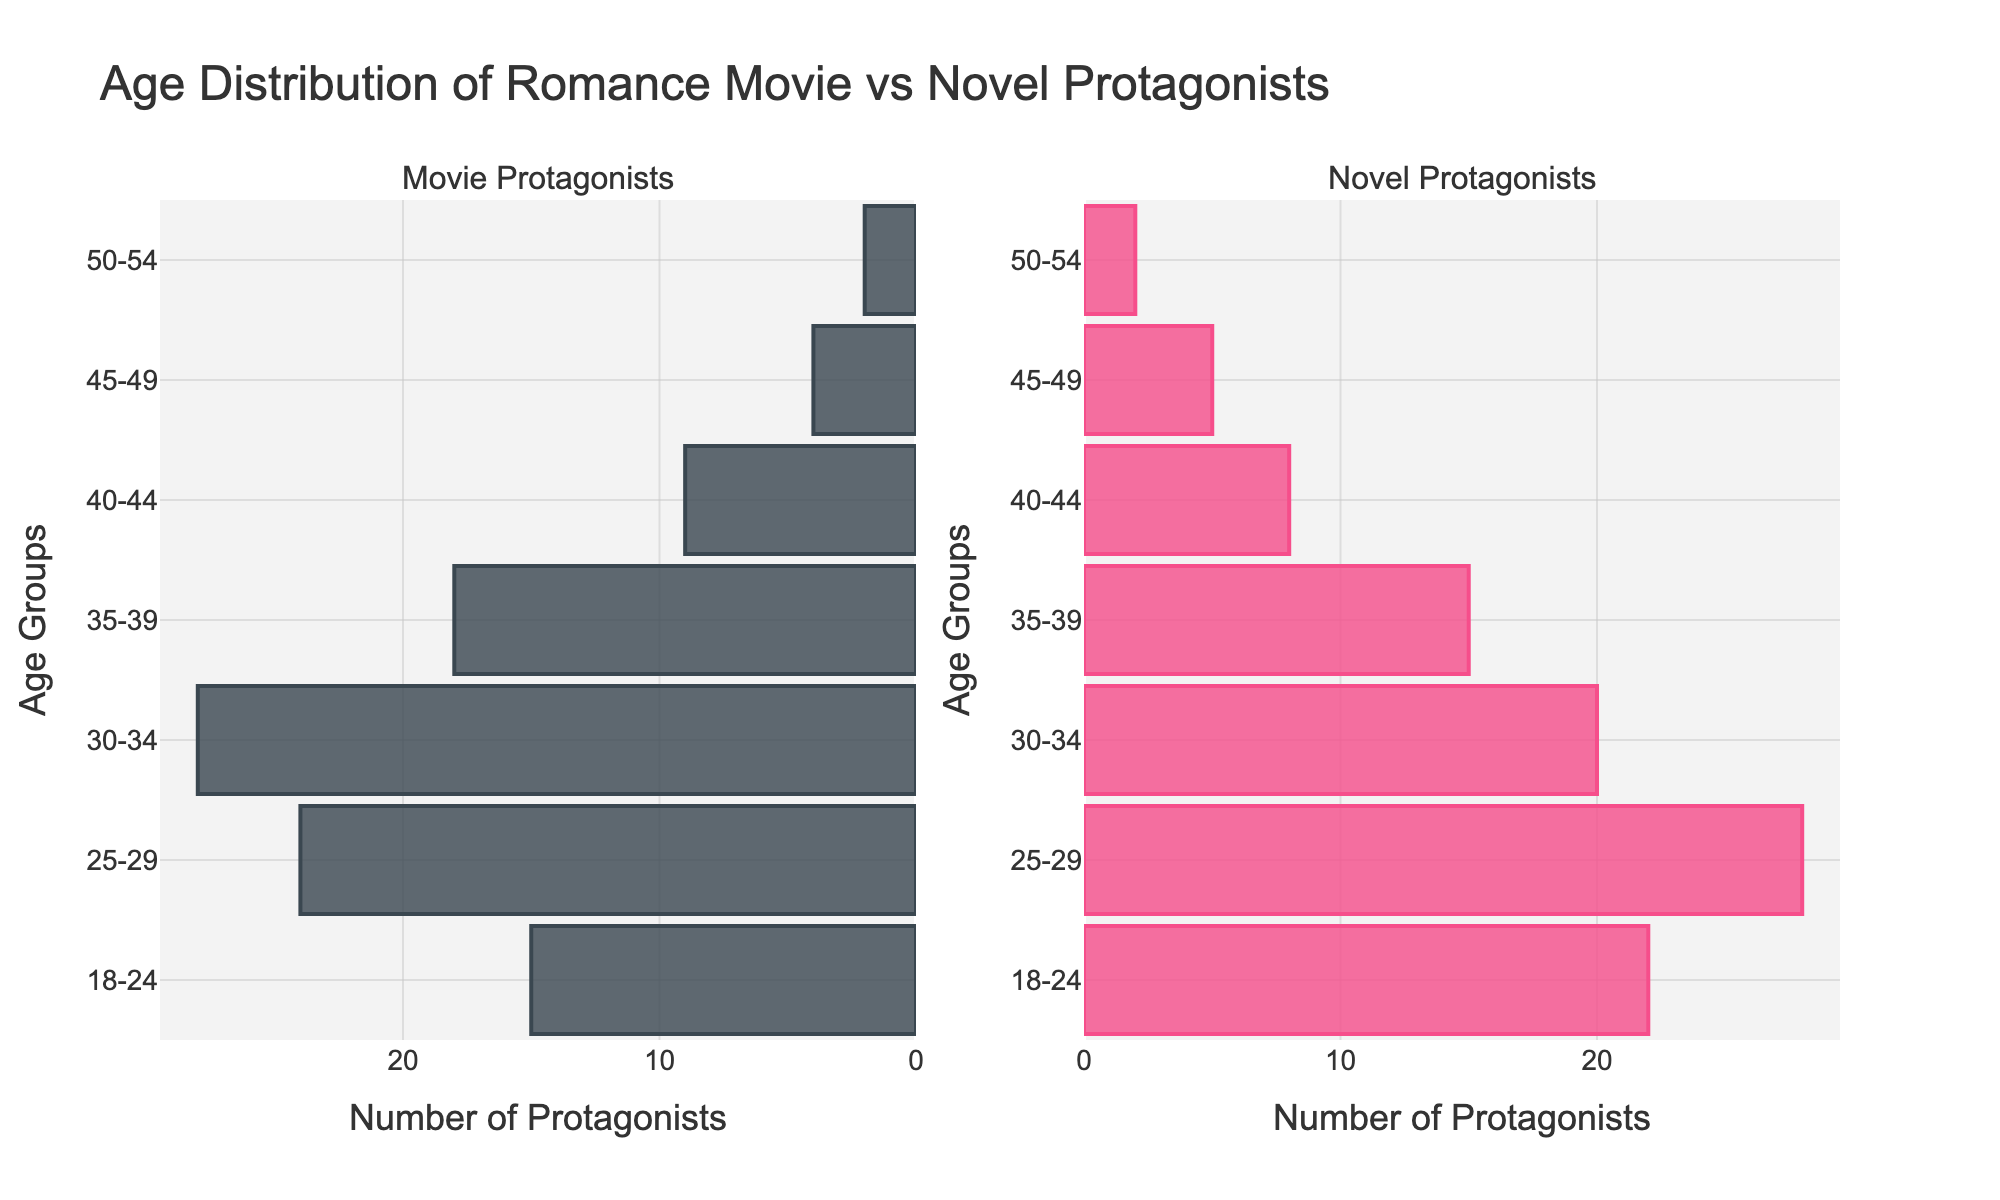What is the title of the figure? The title is displayed at the top of the figure, which provides an overview of the data being presented.
Answer: Age Distribution of Romance Movie vs Novel Protagonists Which age group has the most movie protagonists? By examining the left bar chart that represents movie protagonists, the tallest bar corresponds to the most populous age group.
Answer: 30-34 How many novel protagonists are in the age group 25-29? Look at the right bar chart, find the bar labeled 25-29, and identify the value of the bar.
Answer: 28 What is the total number of movie protagonists shown in the figure? Sum all the values from the left bar chart for each age group: 15 + 24 + 28 + 18 + 9 + 4 + 2. This gives the total number of movie protagonists.
Answer: 100 Which age group has a higher number of protagonists in novels than in movies? Compare each age group's values from both bar charts and identify where the novel's bar is taller than the movie's bar.
Answer: 18-24 What's the average number of movie protagonists across all age groups? Sum all the values from the left chart (15+24+28+18+9+4+2) which equals 100, then divide by the number of age groups (7): 100/7.
Answer: ~14.29 Which age group has the closest number of movie and novel protagonists? Find the bars with the most similar heights in both charts by comparing the values for each age group.
Answer: 50-54 What is the difference in the number of protagonists between movies and novels for the age group 30-34? Subtract the number of novel protagonists (20) from the number of movie protagonists (28) in the age group 30-34.
Answer: 8 In which age group is the disparity between movie and novel protagonists the greatest? Identify the age group with the largest difference between the two bars on the charts.
Answer: 25-29 What is the percentage of novel protagonists in the age group 18-24 compared to the total novel protagonists? Calculate the total number of novel protagonists by summing all values (22+28+20+15+8+5+2=100), then divide the number in 18-24 (22) by the total and multiply by 100 to find the percentage.
Answer: 22% 